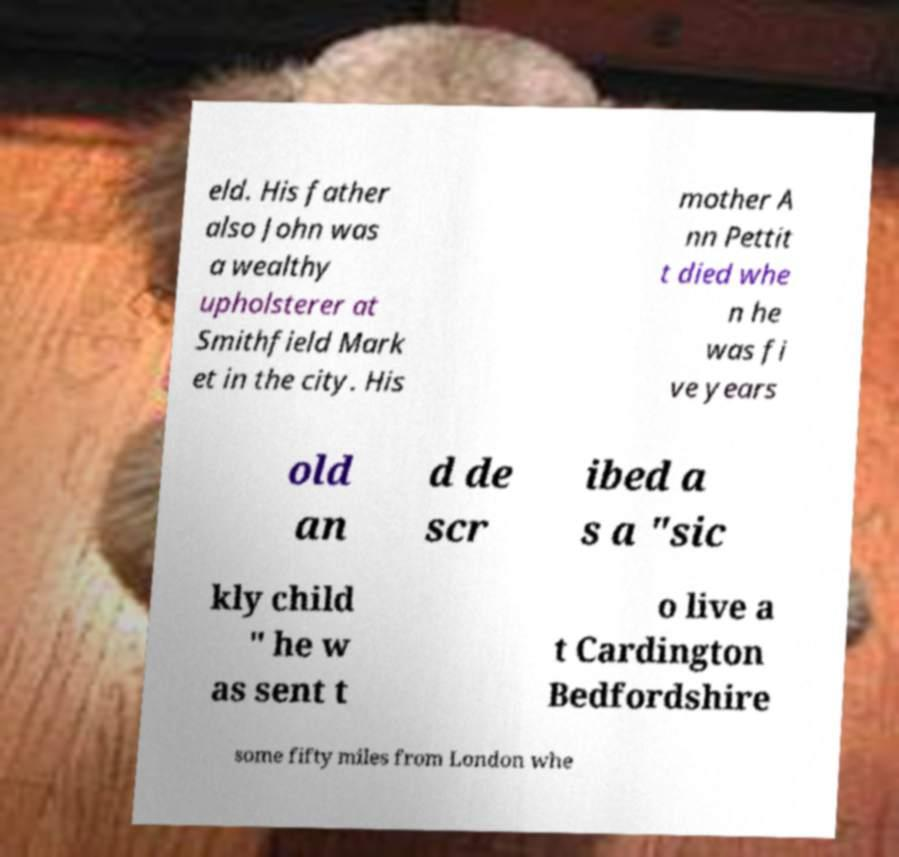Could you assist in decoding the text presented in this image and type it out clearly? eld. His father also John was a wealthy upholsterer at Smithfield Mark et in the city. His mother A nn Pettit t died whe n he was fi ve years old an d de scr ibed a s a "sic kly child " he w as sent t o live a t Cardington Bedfordshire some fifty miles from London whe 